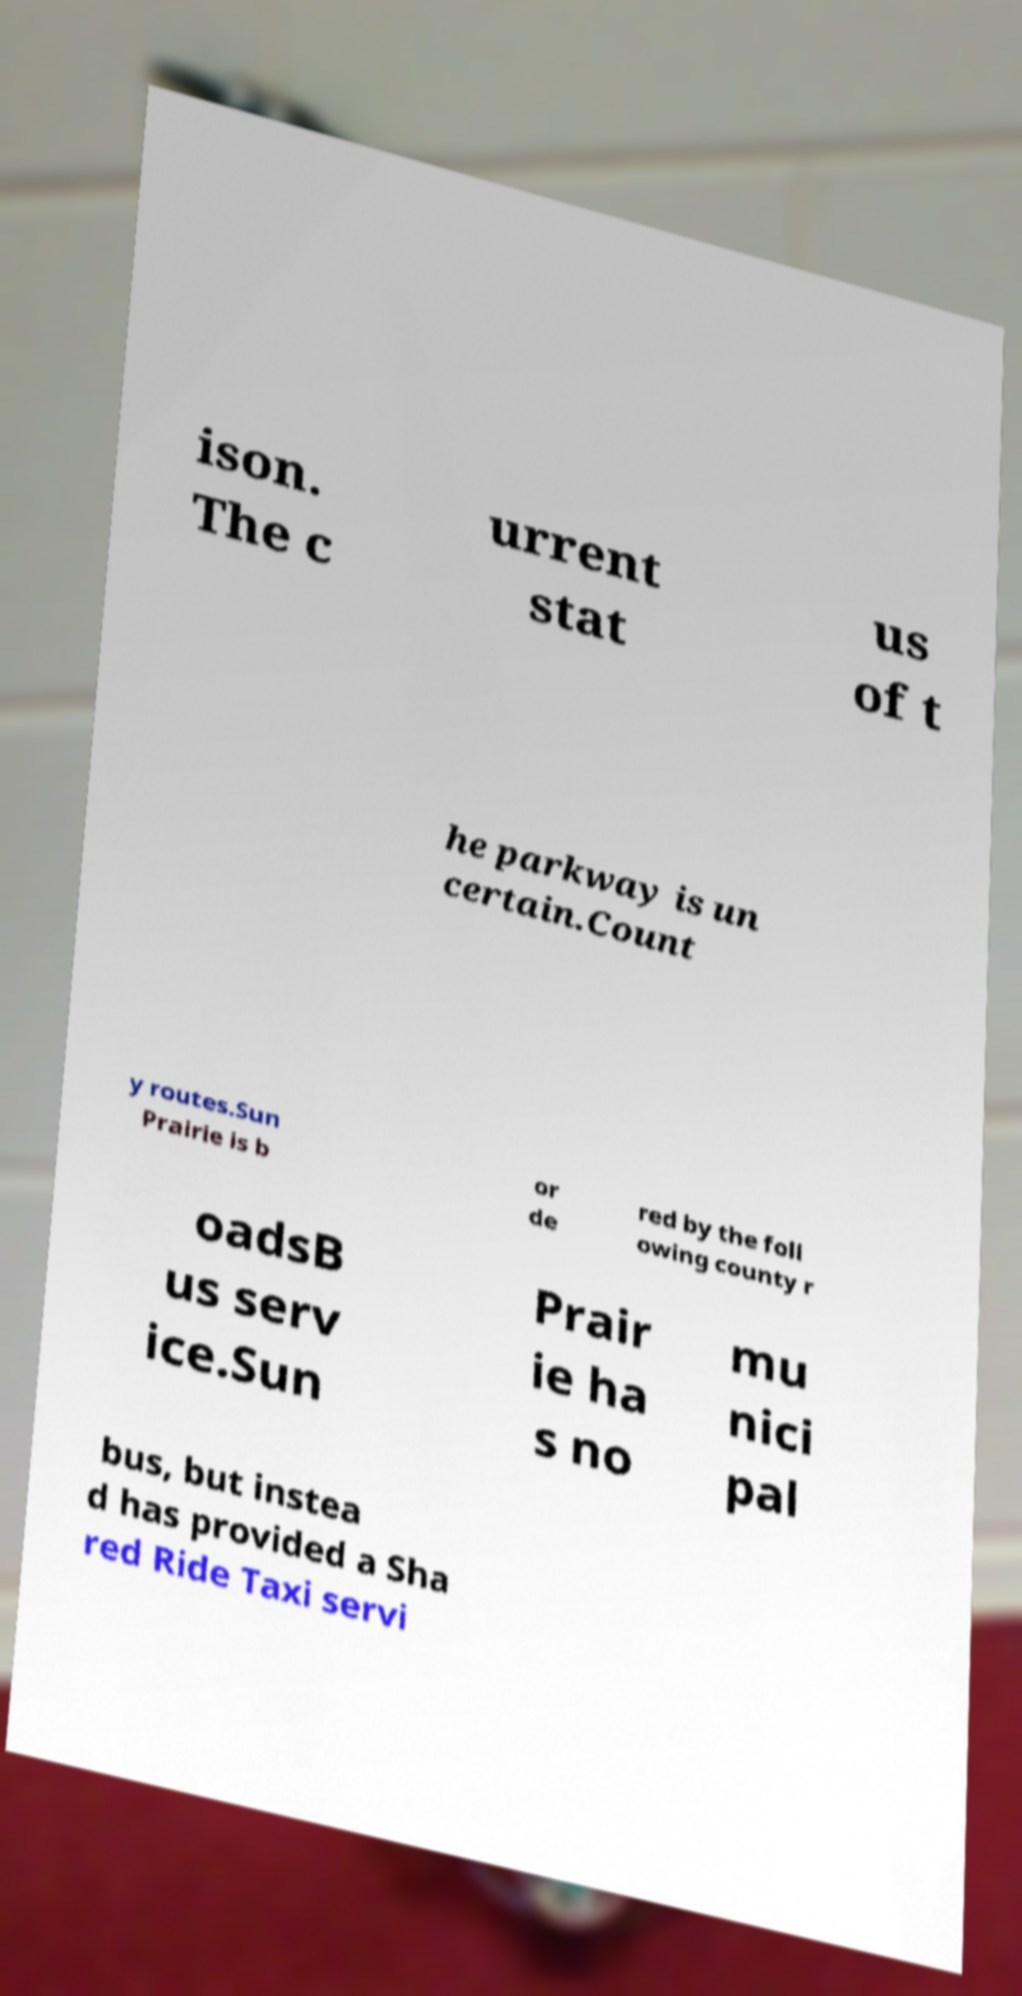For documentation purposes, I need the text within this image transcribed. Could you provide that? ison. The c urrent stat us of t he parkway is un certain.Count y routes.Sun Prairie is b or de red by the foll owing county r oadsB us serv ice.Sun Prair ie ha s no mu nici pal bus, but instea d has provided a Sha red Ride Taxi servi 